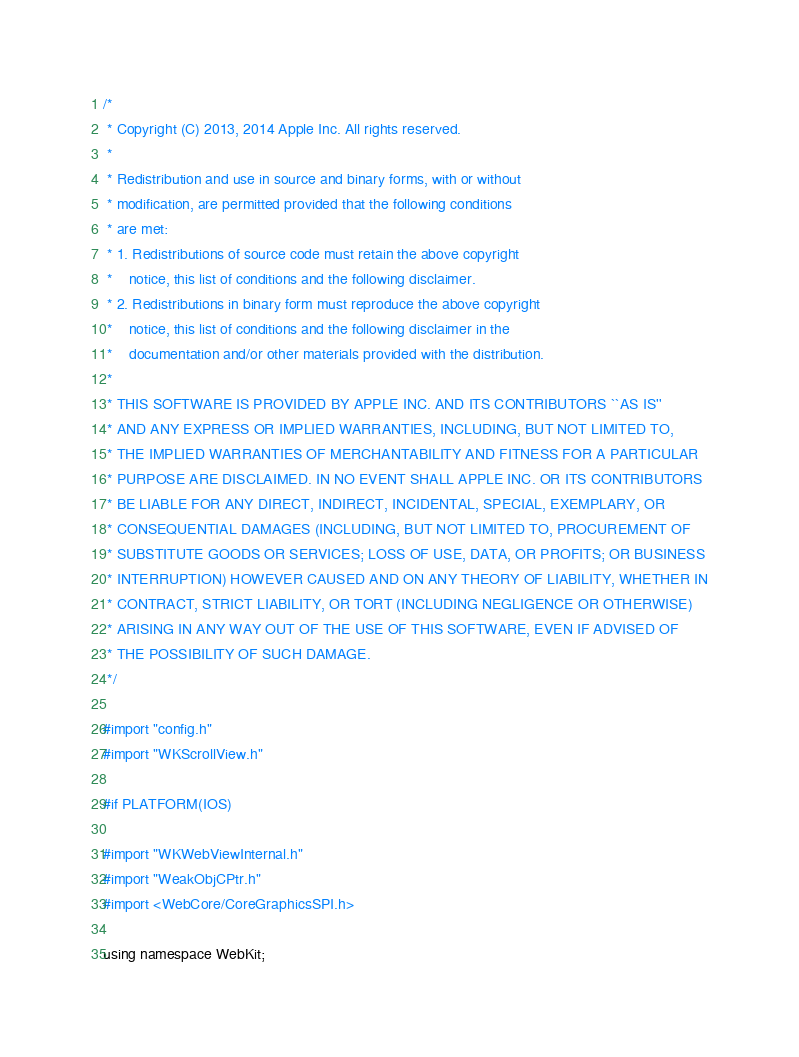<code> <loc_0><loc_0><loc_500><loc_500><_ObjectiveC_>/*
 * Copyright (C) 2013, 2014 Apple Inc. All rights reserved.
 *
 * Redistribution and use in source and binary forms, with or without
 * modification, are permitted provided that the following conditions
 * are met:
 * 1. Redistributions of source code must retain the above copyright
 *    notice, this list of conditions and the following disclaimer.
 * 2. Redistributions in binary form must reproduce the above copyright
 *    notice, this list of conditions and the following disclaimer in the
 *    documentation and/or other materials provided with the distribution.
 *
 * THIS SOFTWARE IS PROVIDED BY APPLE INC. AND ITS CONTRIBUTORS ``AS IS''
 * AND ANY EXPRESS OR IMPLIED WARRANTIES, INCLUDING, BUT NOT LIMITED TO,
 * THE IMPLIED WARRANTIES OF MERCHANTABILITY AND FITNESS FOR A PARTICULAR
 * PURPOSE ARE DISCLAIMED. IN NO EVENT SHALL APPLE INC. OR ITS CONTRIBUTORS
 * BE LIABLE FOR ANY DIRECT, INDIRECT, INCIDENTAL, SPECIAL, EXEMPLARY, OR
 * CONSEQUENTIAL DAMAGES (INCLUDING, BUT NOT LIMITED TO, PROCUREMENT OF
 * SUBSTITUTE GOODS OR SERVICES; LOSS OF USE, DATA, OR PROFITS; OR BUSINESS
 * INTERRUPTION) HOWEVER CAUSED AND ON ANY THEORY OF LIABILITY, WHETHER IN
 * CONTRACT, STRICT LIABILITY, OR TORT (INCLUDING NEGLIGENCE OR OTHERWISE)
 * ARISING IN ANY WAY OUT OF THE USE OF THIS SOFTWARE, EVEN IF ADVISED OF
 * THE POSSIBILITY OF SUCH DAMAGE.
 */

#import "config.h"
#import "WKScrollView.h"

#if PLATFORM(IOS)

#import "WKWebViewInternal.h"
#import "WeakObjCPtr.h"
#import <WebCore/CoreGraphicsSPI.h>

using namespace WebKit;
</code> 